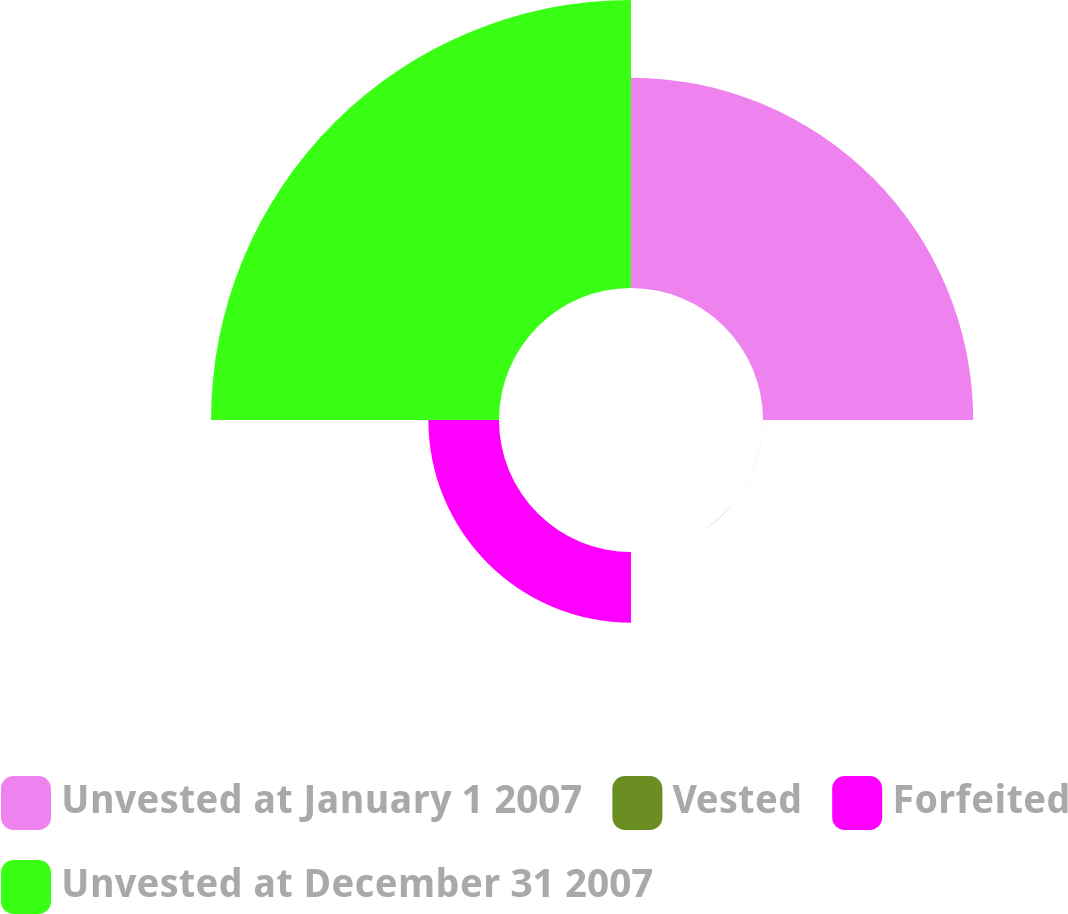<chart> <loc_0><loc_0><loc_500><loc_500><pie_chart><fcel>Unvested at January 1 2007<fcel>Vested<fcel>Forfeited<fcel>Unvested at December 31 2007<nl><fcel>36.95%<fcel>0.01%<fcel>12.42%<fcel>50.62%<nl></chart> 